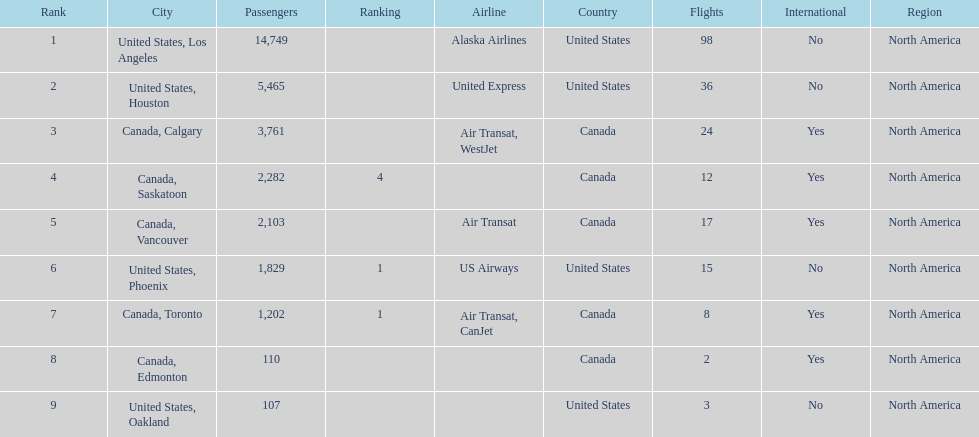Was los angeles or houston the busiest international route at manzanillo international airport in 2013? Los Angeles. 